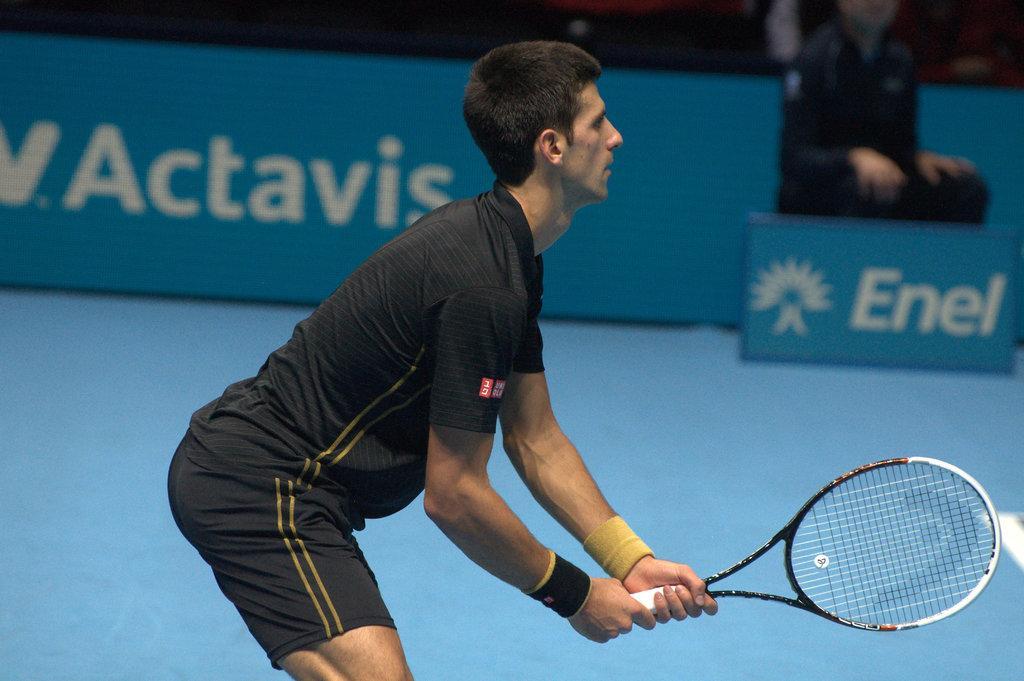Can you describe this image briefly? In this image djokovic is playing the tennis by holding the bat. In the background person is sitting. 